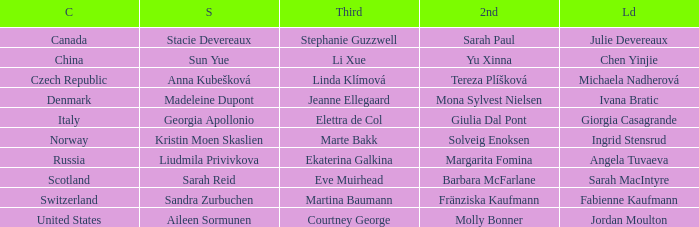What skip has martina baumann as the third? Sandra Zurbuchen. 